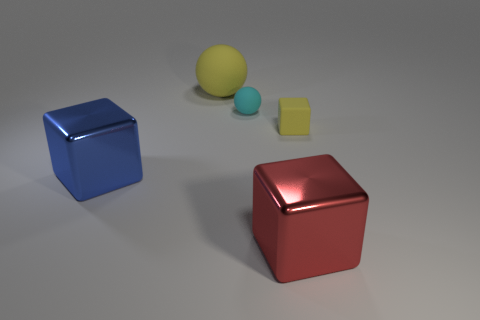What is the block on the left side of the cyan ball made of?
Provide a short and direct response. Metal. Is there any other thing that is the same color as the small block?
Ensure brevity in your answer.  Yes. What is the shape of the large red thing?
Provide a short and direct response. Cube. What number of things are left of the tiny yellow block and right of the large blue cube?
Offer a terse response. 3. Is the large matte sphere the same color as the tiny matte cube?
Your answer should be very brief. Yes. There is a large blue thing that is the same shape as the small yellow matte object; what material is it?
Offer a terse response. Metal. Is there any other thing that is made of the same material as the large blue object?
Ensure brevity in your answer.  Yes. Are there an equal number of metal blocks that are behind the blue shiny thing and blue objects that are in front of the large red cube?
Your answer should be compact. Yes. Are the red cube and the large blue thing made of the same material?
Your answer should be very brief. Yes. How many blue objects are either large metallic cubes or rubber blocks?
Your answer should be very brief. 1. 